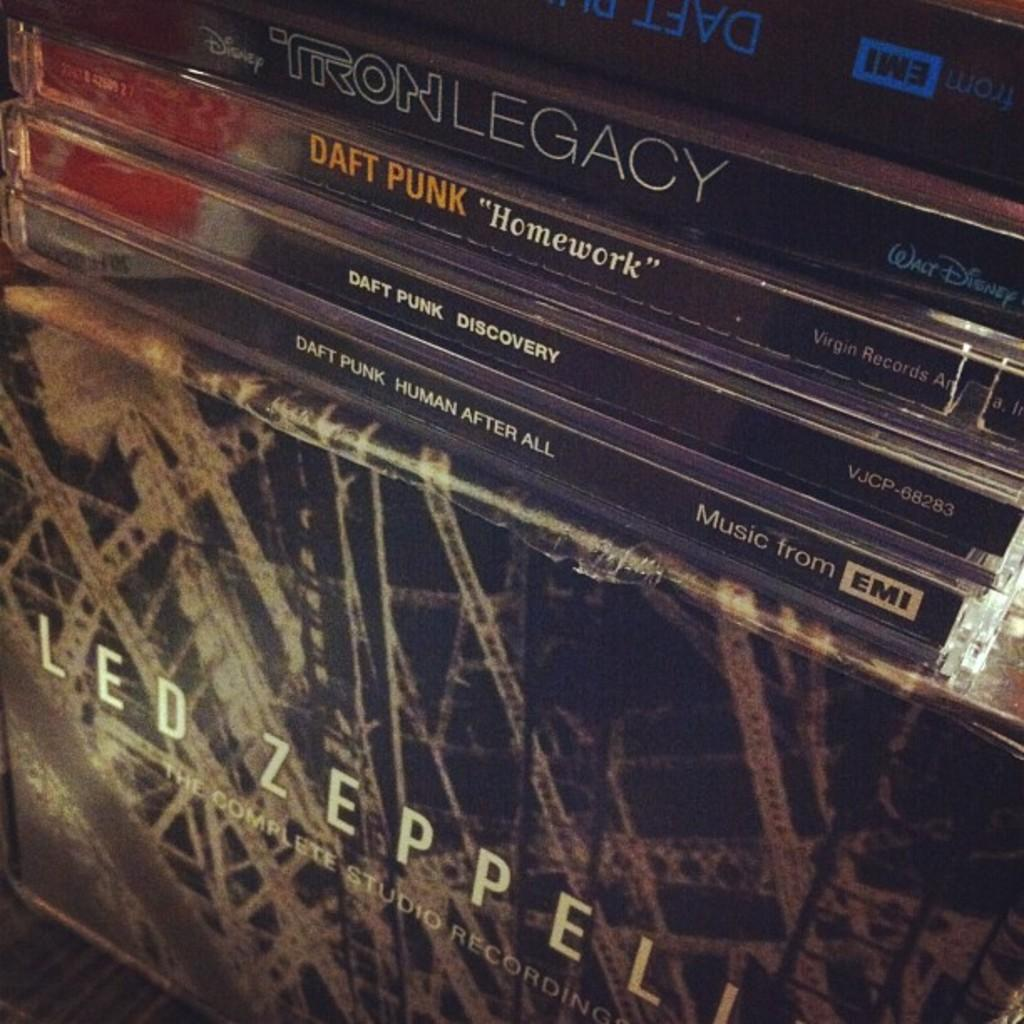<image>
Write a terse but informative summary of the picture. A stack of compact disc including Led Zeppeli . 